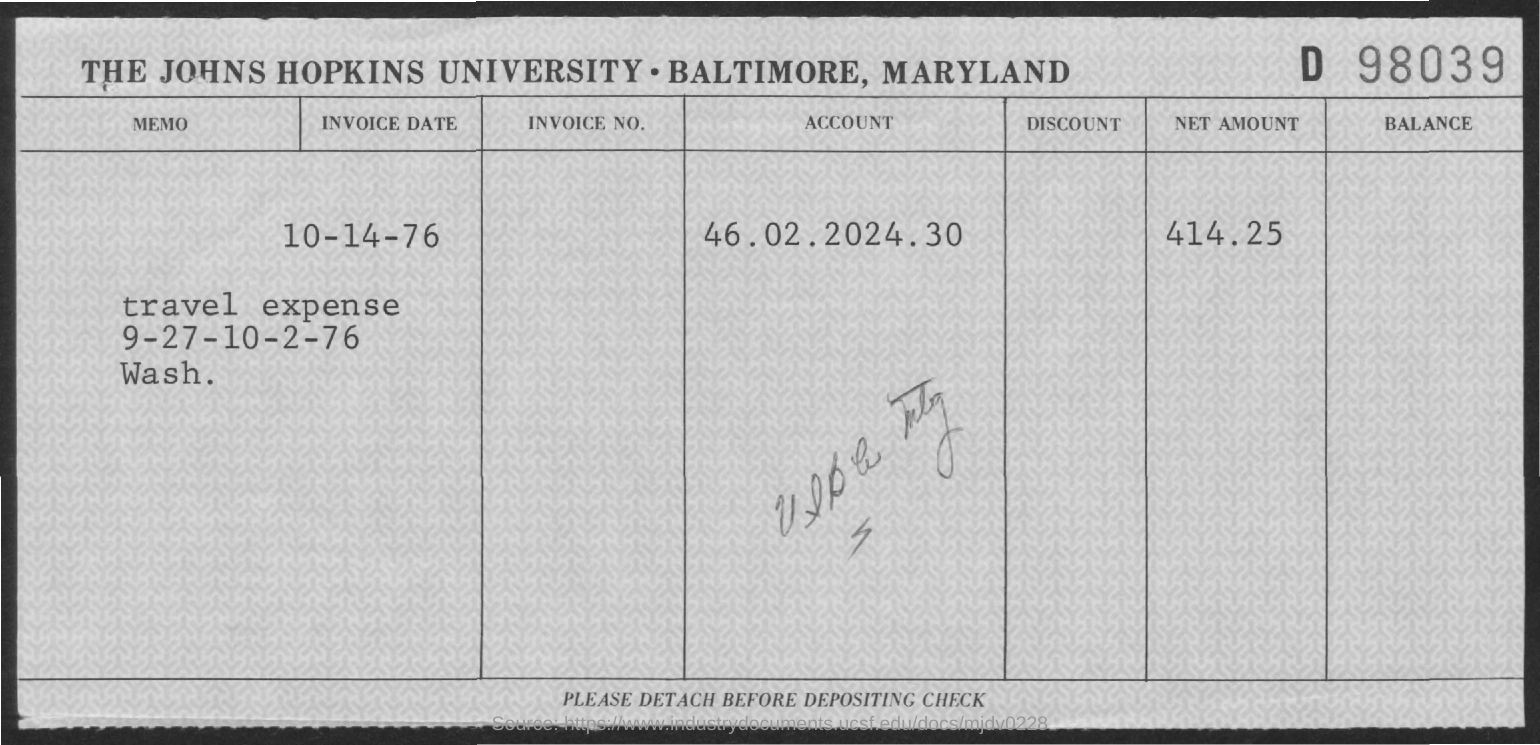Draw attention to some important aspects in this diagram. What is the account number?" she asked, her voice laced with concern. "It is 46.02.2024.30...," he replied, his words carrying a sense of urgency. The invoice date is October 14, 1976. The net amount is 414.25. 